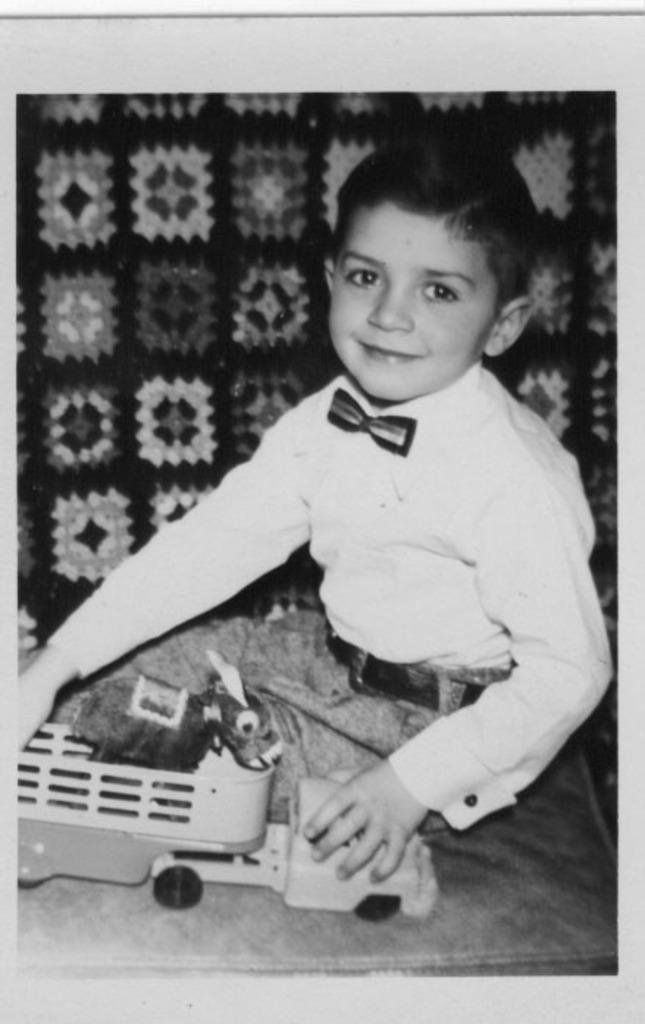What type of image is this? The image is a black and white photograph. Who or what is the main subject in the photograph? There is a child in the photograph. What is the child doing in the photograph? The child is sitting on a surface. What object is the child holding in the photograph? The child is holding a toy truck. What country is visible in the background of the photograph? There is no country visible in the background of the photograph, as it is a black and white image with no visible background. 